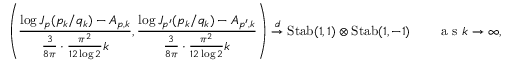Convert formula to latex. <formula><loc_0><loc_0><loc_500><loc_500>\left ( \frac { \log J _ { p } ( p _ { k } / q _ { k } ) - A _ { p , k } } { \frac { 3 } { 8 \pi } \cdot \frac { \pi ^ { 2 } } { 1 2 \log 2 } k } , \frac { \log J _ { p ^ { \prime } } ( p _ { k } / q _ { k } ) - A _ { p ^ { \prime } , k } } { \frac { 3 } { 8 \pi } \cdot \frac { \pi ^ { 2 } } { 1 2 \log 2 } k } \right ) \overset { d } { \to } S t a b ( 1 , 1 ) \otimes S t a b ( 1 , - 1 ) \quad a s k \to \infty ,</formula> 